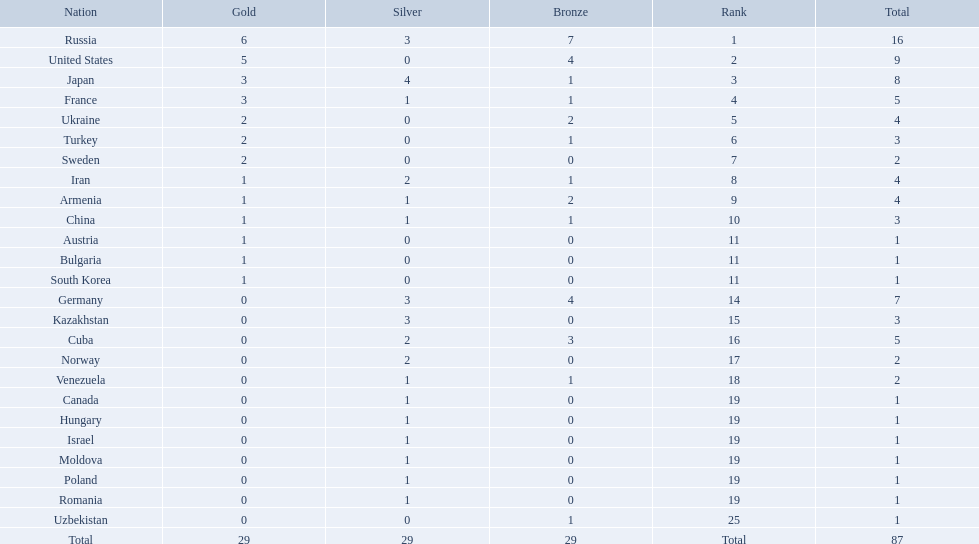Which nations are there? Russia, 6, United States, 5, Japan, 3, France, 3, Ukraine, 2, Turkey, 2, Sweden, 2, Iran, 1, Armenia, 1, China, 1, Austria, 1, Bulgaria, 1, South Korea, 1, Germany, 0, Kazakhstan, 0, Cuba, 0, Norway, 0, Venezuela, 0, Canada, 0, Hungary, 0, Israel, 0, Moldova, 0, Poland, 0, Romania, 0, Uzbekistan, 0. Which nations won gold? Russia, 6, United States, 5, Japan, 3, France, 3, Ukraine, 2, Turkey, 2, Sweden, 2, Iran, 1, Armenia, 1, China, 1, Austria, 1, Bulgaria, 1, South Korea, 1. How many golds did united states win? United States, 5. Which country has more than 5 gold medals? Russia, 6. What country is it? Russia. 